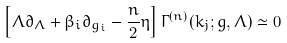Convert formula to latex. <formula><loc_0><loc_0><loc_500><loc_500>\left [ \Lambda \partial _ { \Lambda } + \beta _ { i } \partial _ { g _ { i } } - \frac { n } { 2 } \eta \right ] \Gamma ^ { ( n ) } ( k _ { j } ; g , \Lambda ) \simeq 0</formula> 